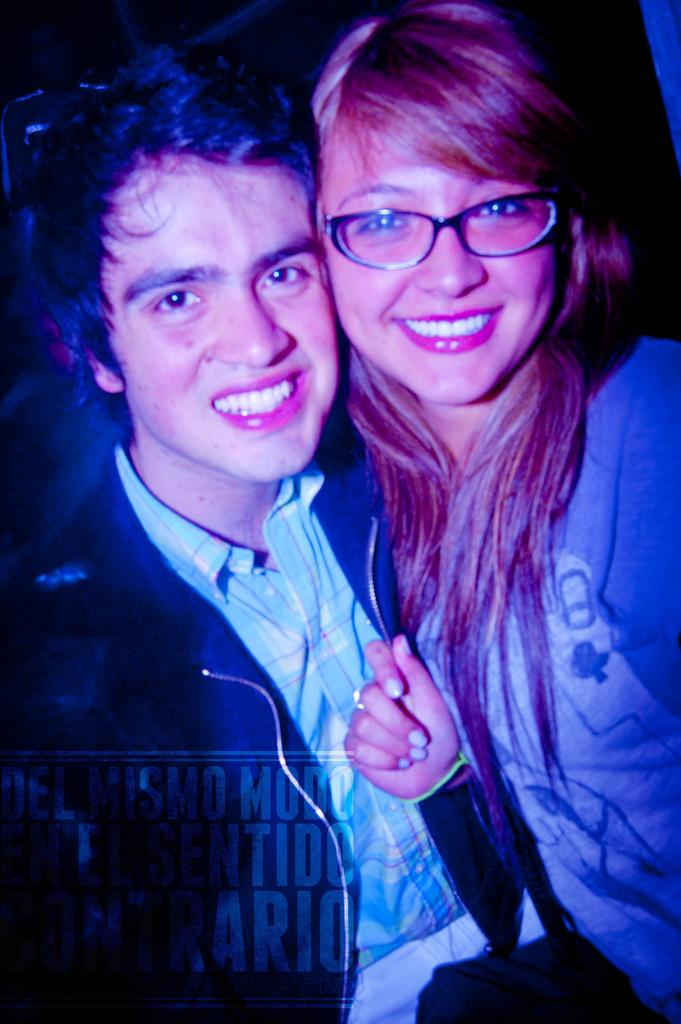How many people are in the image? There are two people in the image. What is the facial expression of the people in the image? The people are smiling. What else can be seen in the image besides the people? There is some text visible in the image. What is the color of the background in the image? The background of the image is dark. Can you tell me how many brushes are being used by the people in the image? There is no indication in the image that the people are using brushes, so it cannot be determined from the picture. 